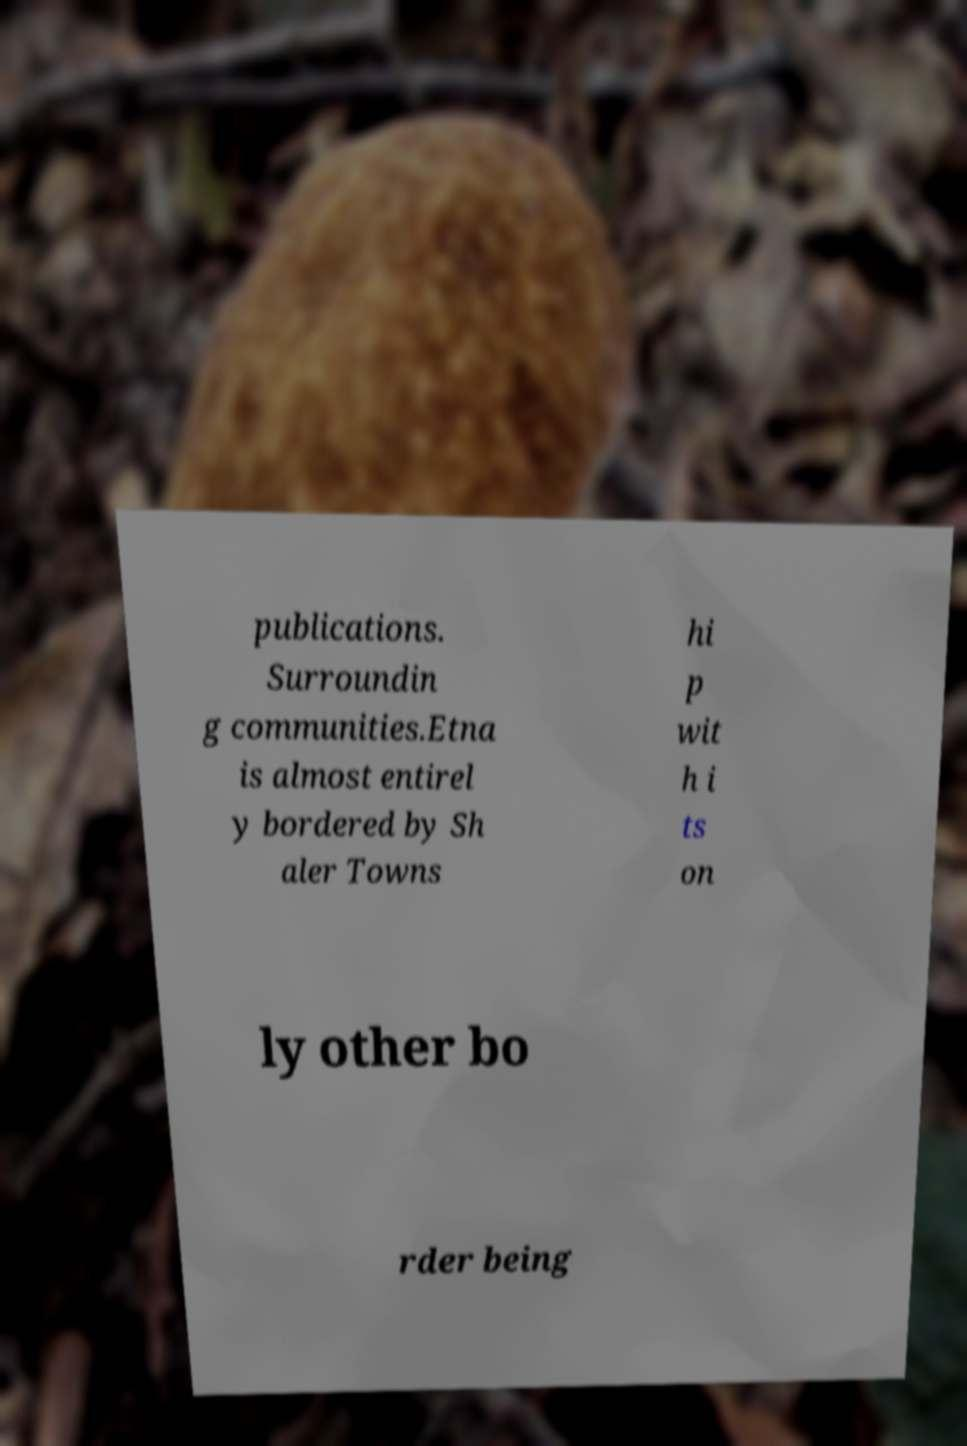Please read and relay the text visible in this image. What does it say? publications. Surroundin g communities.Etna is almost entirel y bordered by Sh aler Towns hi p wit h i ts on ly other bo rder being 